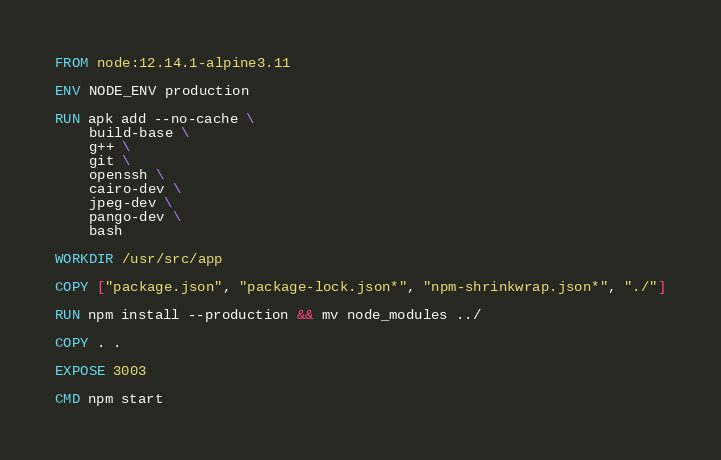<code> <loc_0><loc_0><loc_500><loc_500><_Dockerfile_>FROM node:12.14.1-alpine3.11

ENV NODE_ENV production

RUN apk add --no-cache \
    build-base \
    g++ \
    git \
    openssh \
    cairo-dev \
    jpeg-dev \
    pango-dev \
    bash

WORKDIR /usr/src/app

COPY ["package.json", "package-lock.json*", "npm-shrinkwrap.json*", "./"]

RUN npm install --production && mv node_modules ../

COPY . .

EXPOSE 3003

CMD npm start</code> 